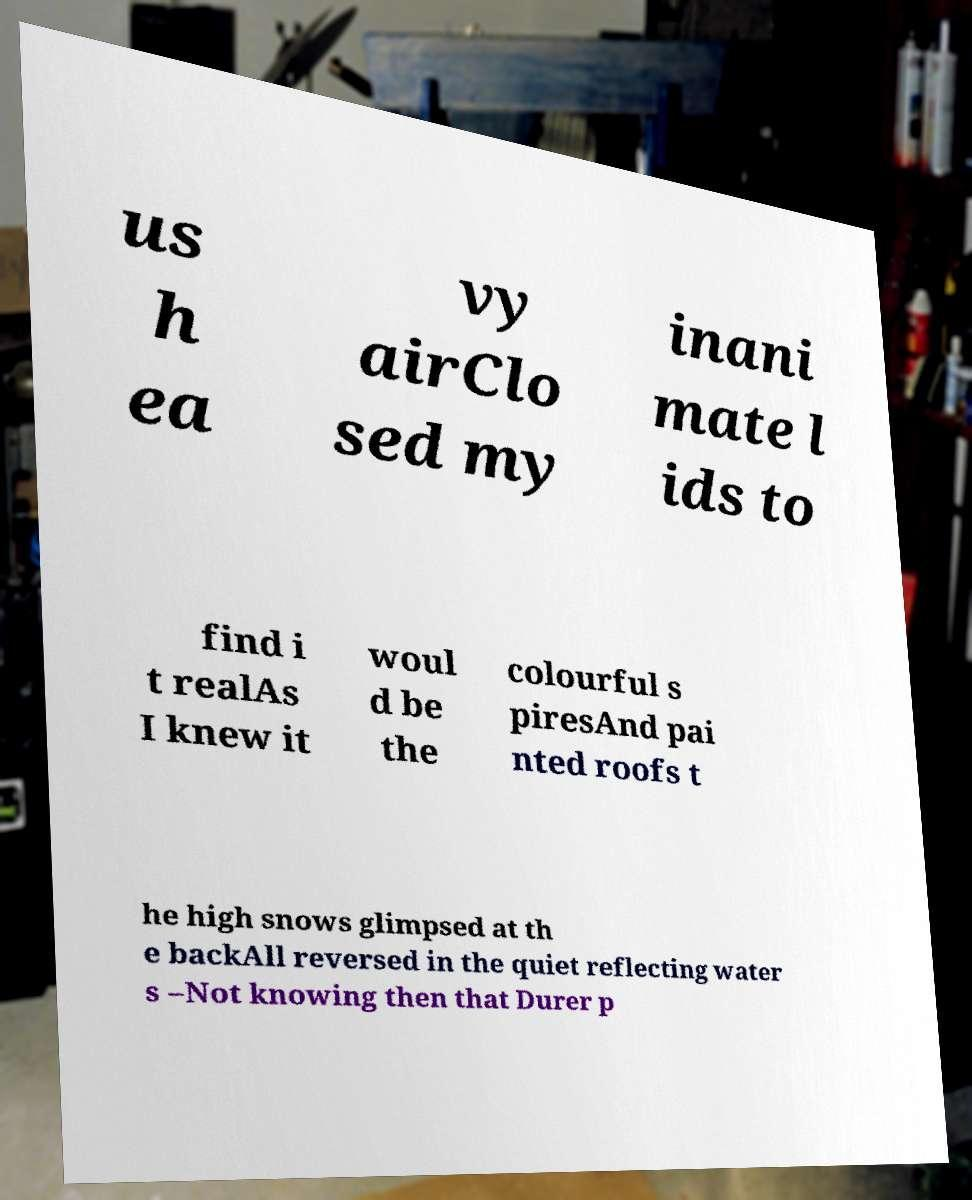Can you read and provide the text displayed in the image?This photo seems to have some interesting text. Can you extract and type it out for me? us h ea vy airClo sed my inani mate l ids to find i t realAs I knew it woul d be the colourful s piresAnd pai nted roofs t he high snows glimpsed at th e backAll reversed in the quiet reflecting water s –Not knowing then that Durer p 